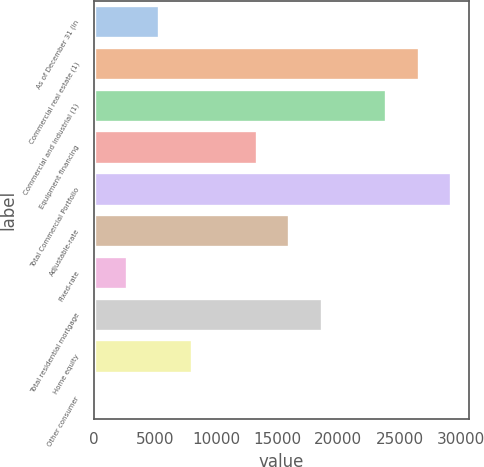<chart> <loc_0><loc_0><loc_500><loc_500><bar_chart><fcel>As of December 31 (in<fcel>Commercial real estate (1)<fcel>Commercial and industrial (1)<fcel>Equipment financing<fcel>Total Commercial Portfolio<fcel>Adjustable-rate<fcel>Fixed-rate<fcel>Total residential mortgage<fcel>Home equity<fcel>Other consumer<nl><fcel>5364.4<fcel>26592<fcel>23938.5<fcel>13324.8<fcel>29245.5<fcel>15978.2<fcel>2710.95<fcel>18631.7<fcel>8017.85<fcel>57.5<nl></chart> 